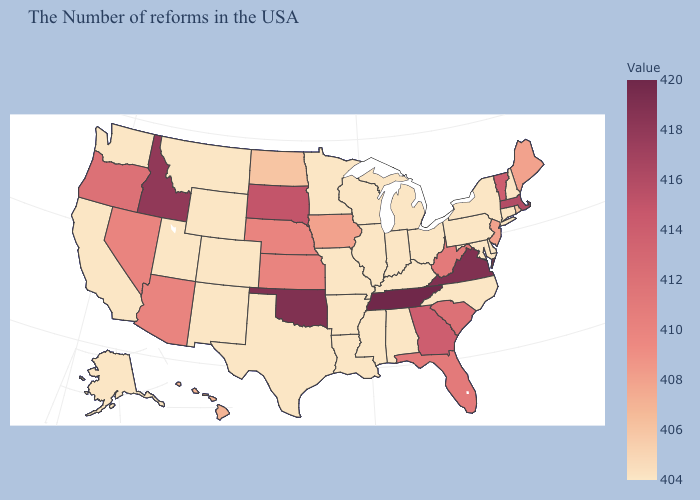Which states have the highest value in the USA?
Short answer required. Tennessee. Which states have the lowest value in the USA?
Quick response, please. New Hampshire, Connecticut, New York, Delaware, Maryland, Pennsylvania, North Carolina, Ohio, Michigan, Kentucky, Indiana, Alabama, Wisconsin, Illinois, Mississippi, Louisiana, Missouri, Arkansas, Minnesota, Texas, Wyoming, Colorado, New Mexico, Utah, Montana, California, Washington, Alaska. Among the states that border Colorado , which have the lowest value?
Write a very short answer. Wyoming, New Mexico, Utah. 